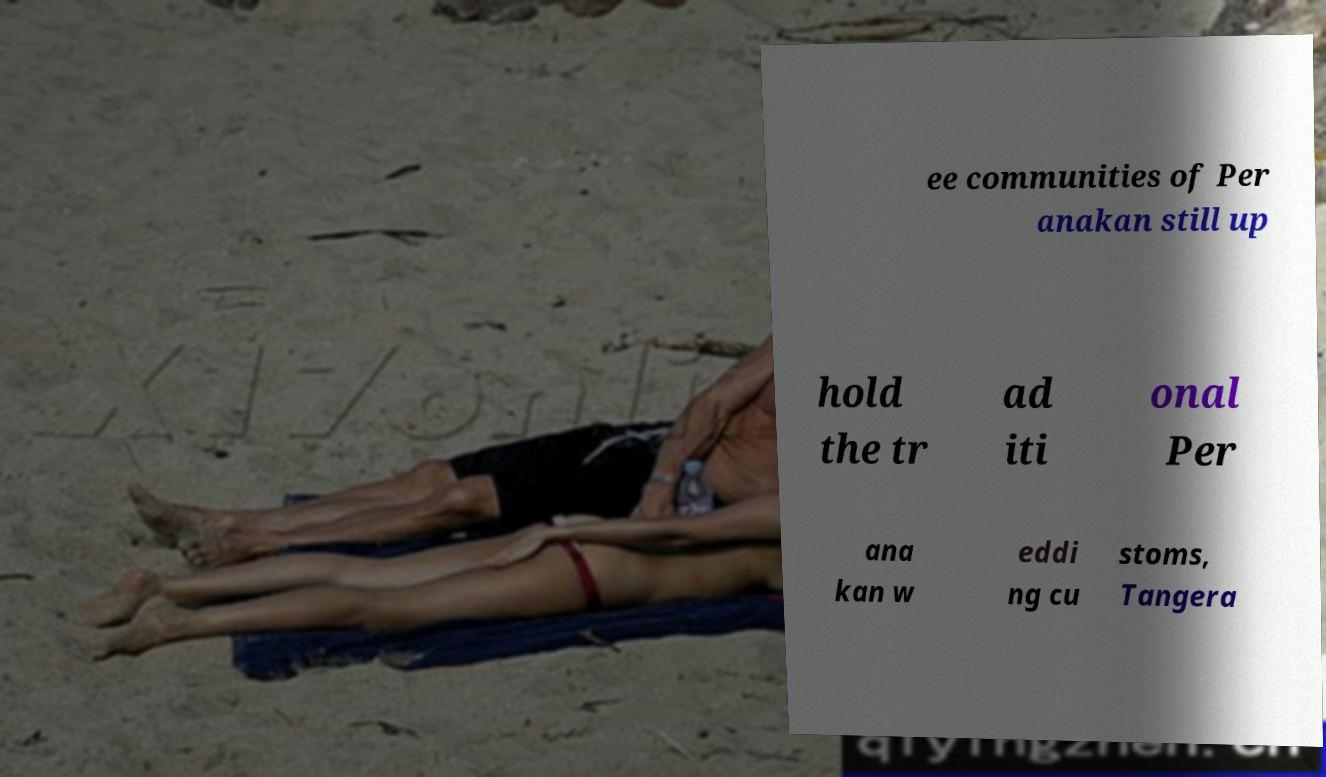Could you assist in decoding the text presented in this image and type it out clearly? ee communities of Per anakan still up hold the tr ad iti onal Per ana kan w eddi ng cu stoms, Tangera 